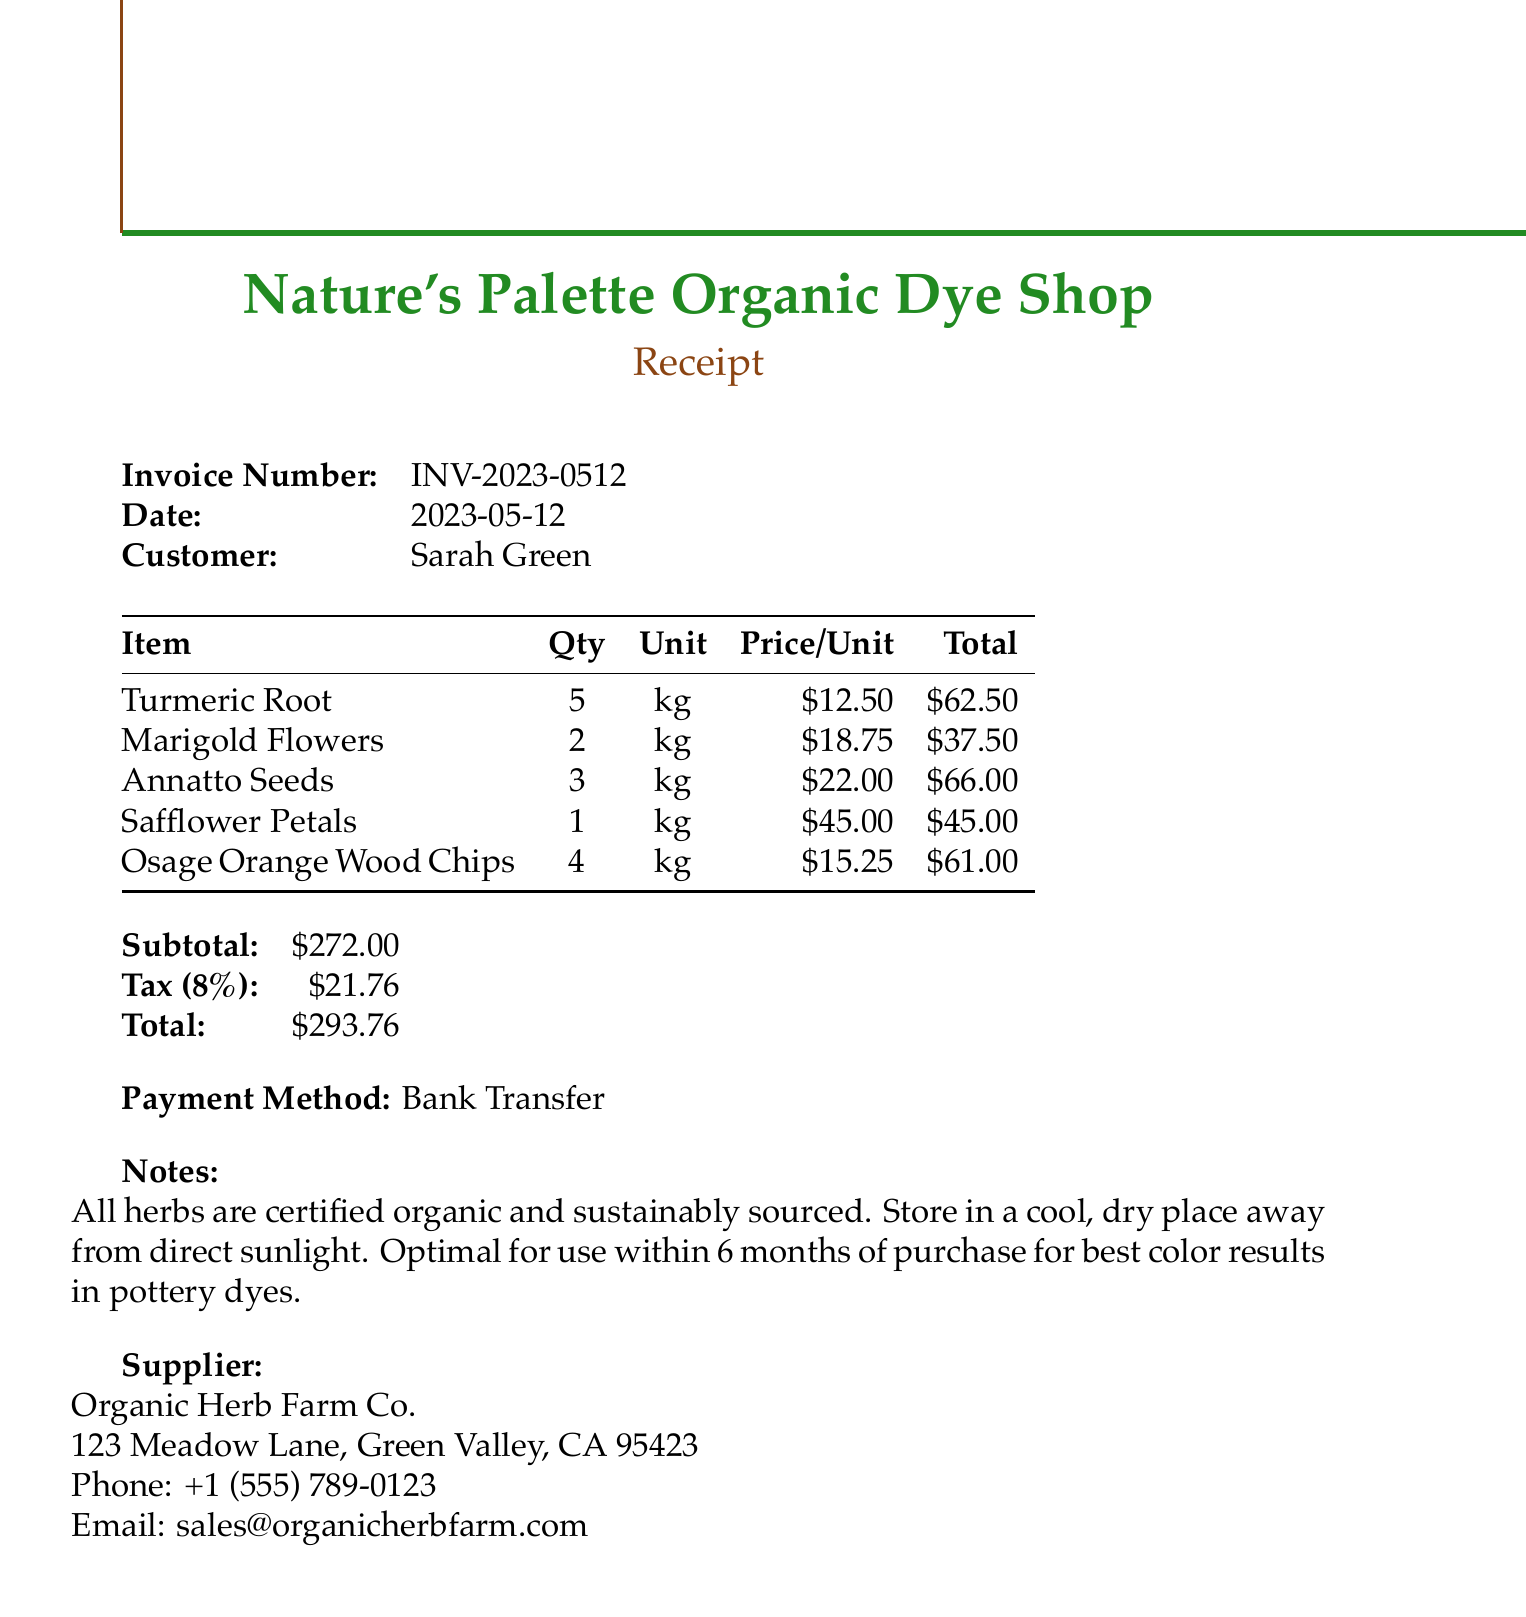What is the invoice number? The invoice number listed in the document for the transaction is crucial for record-keeping.
Answer: INV-2023-0512 What is the date of the invoice? The date indicates when the purchase was made and is important for tracking orders.
Answer: 2023-05-12 Who is the customer? Identifying the customer helps clarify who made the purchase and is important for service records.
Answer: Sarah Green What is the total amount due? The total amount reflects what needs to be paid and includes subtotal and tax.
Answer: $293.76 Which item has the highest price per unit? Determining the item with the highest price assists in understanding cost allocation.
Answer: Safflower Petals How many kilograms of Annatto Seeds were ordered? This question checks the quantity ordered for specific planning and usage in the shop.
Answer: 3 kg What is the tax rate applied in this invoice? Knowing the tax rate is helpful for computations and understanding total price breakdowns.
Answer: 8% What payment method was used? The payment method provides insight into how the purchase was processed financially.
Answer: Bank Transfer What are the notes regarding the herbs? Notes about product handling can prevent misuse and ensure quality results.
Answer: All herbs are certified organic and sustainably sourced. Store in a cool, dry place away from direct sunlight. Optimal for use within 6 months of purchase for best color results in pottery dyes 